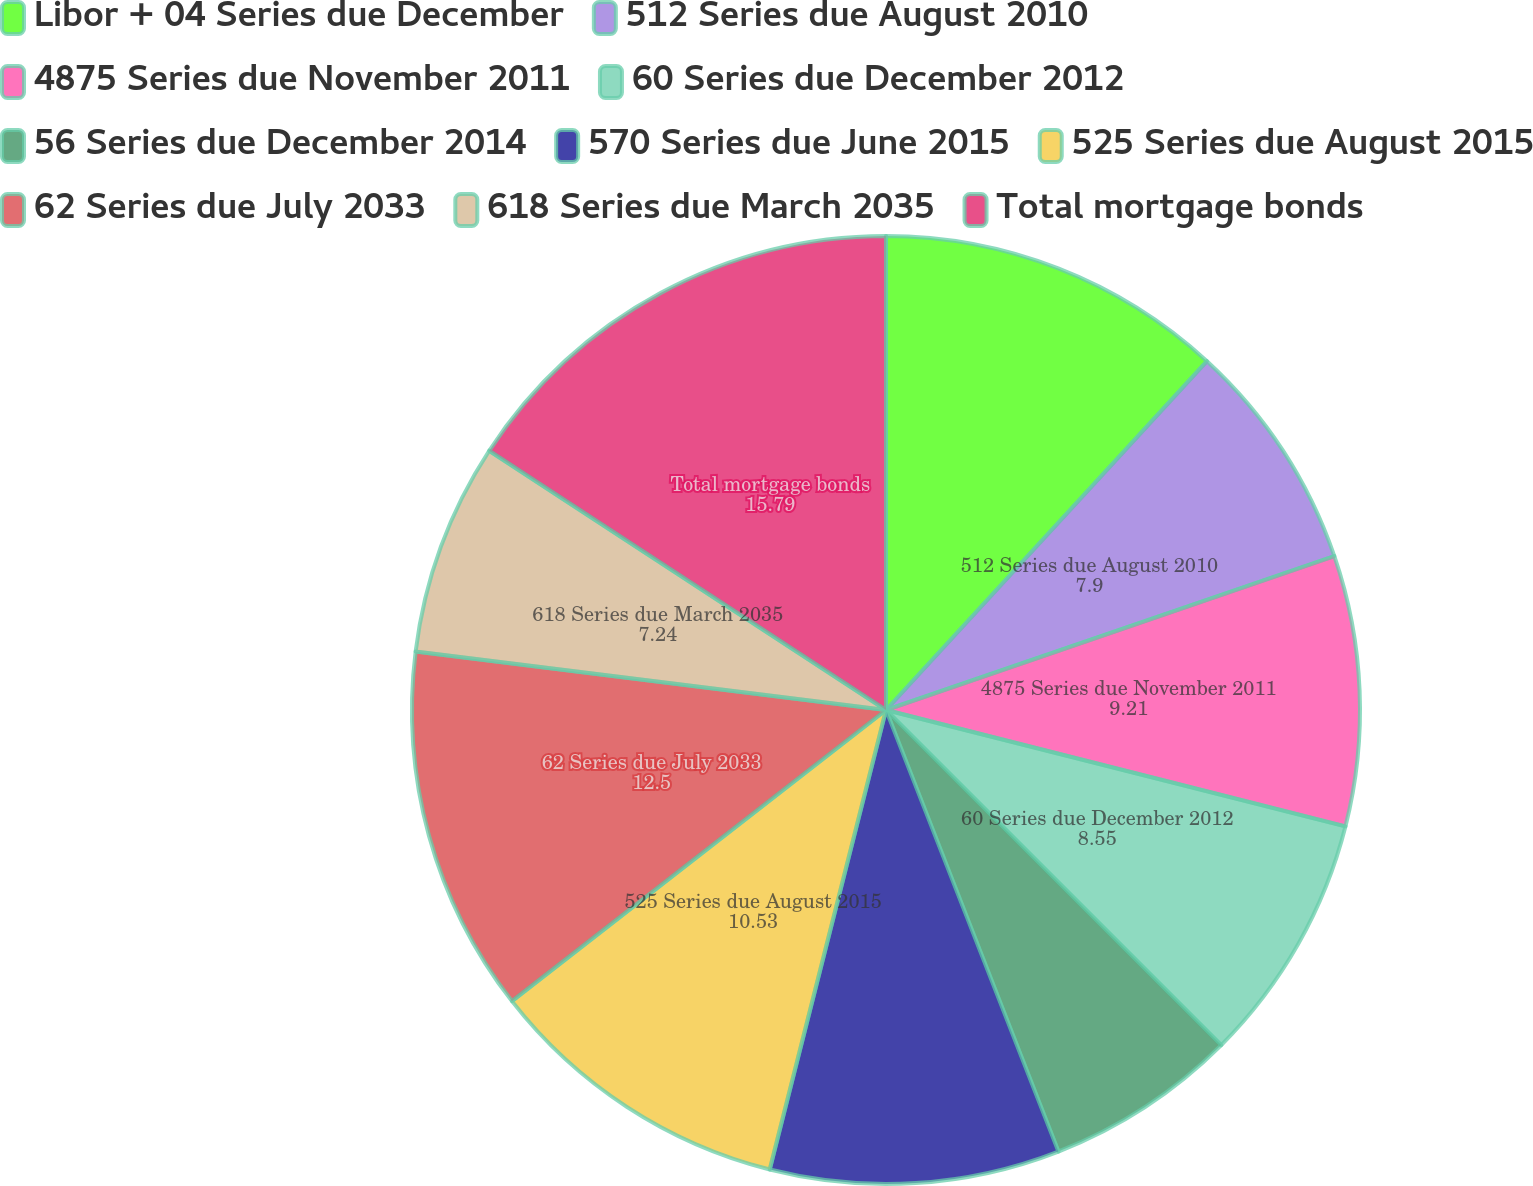Convert chart. <chart><loc_0><loc_0><loc_500><loc_500><pie_chart><fcel>Libor + 04 Series due December<fcel>512 Series due August 2010<fcel>4875 Series due November 2011<fcel>60 Series due December 2012<fcel>56 Series due December 2014<fcel>570 Series due June 2015<fcel>525 Series due August 2015<fcel>62 Series due July 2033<fcel>618 Series due March 2035<fcel>Total mortgage bonds<nl><fcel>11.84%<fcel>7.9%<fcel>9.21%<fcel>8.55%<fcel>6.58%<fcel>9.87%<fcel>10.53%<fcel>12.5%<fcel>7.24%<fcel>15.79%<nl></chart> 